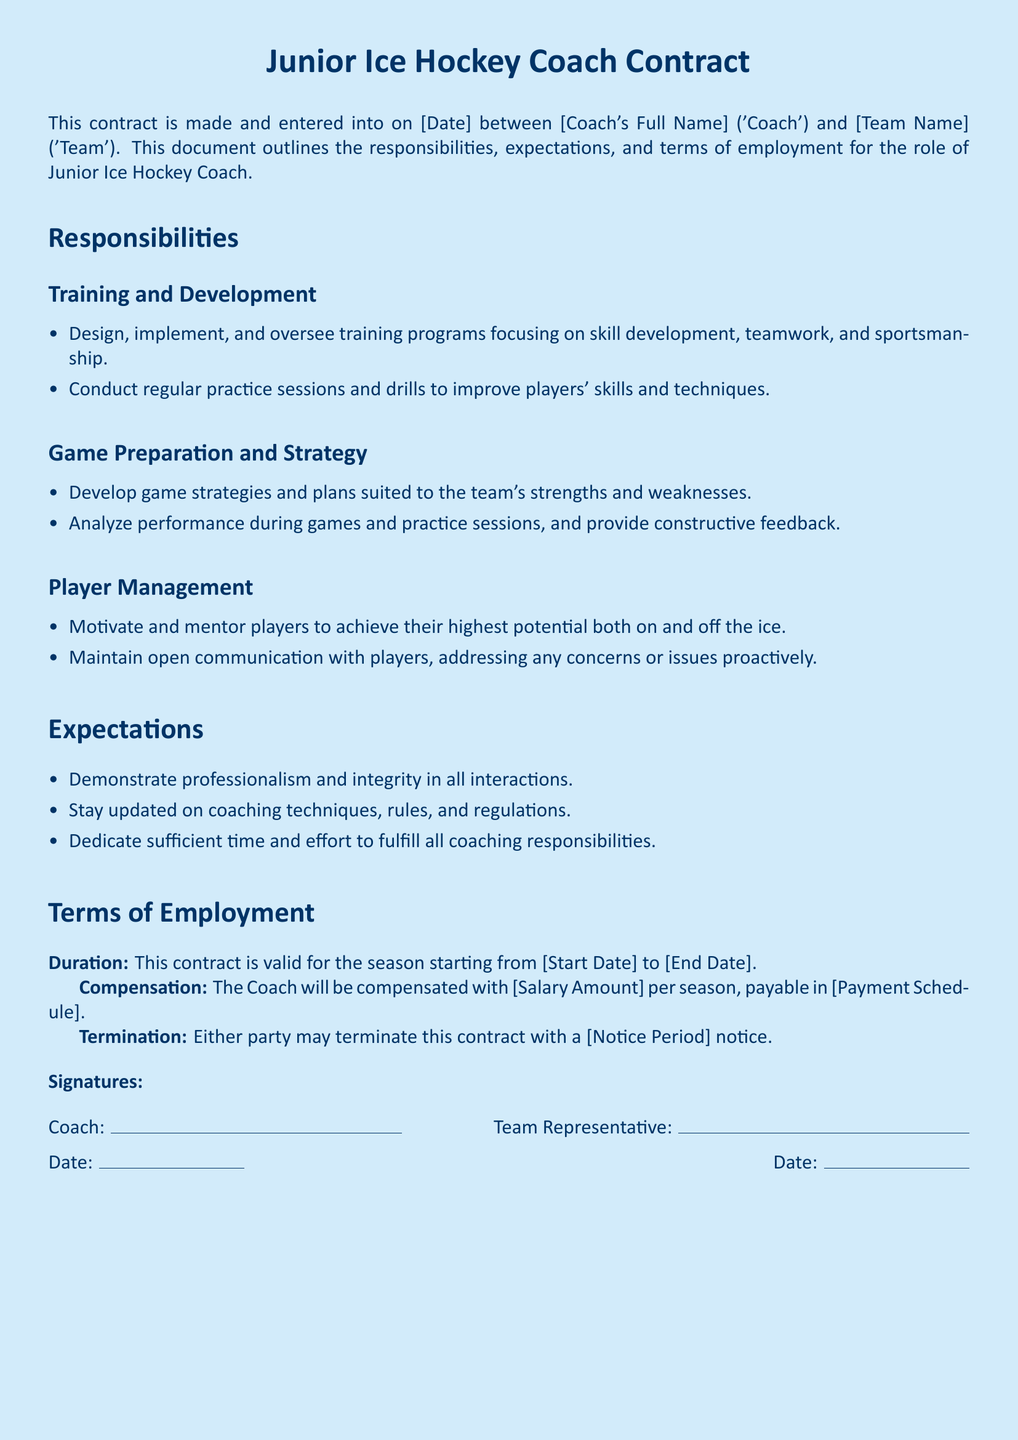What is the effective date of the contract? The effective date of the contract is specified in the section that says it is made on [Date].
Answer: [Date] What is the duration of the contract? The duration is specified in the section stating the contract is valid for the season from [Start Date] to [End Date].
Answer: [Start Date] to [End Date] What is the Coach's full name? The Coach's full name is mentioned at the beginning of the contract under the terms 'Coach' and '[Coach's Full Name]'.
Answer: [Coach's Full Name] What is the salary amount for the Coach? The contract specifies the compensation for the Coach as [Salary Amount] per season.
Answer: [Salary Amount] What is one responsibility of the Coach regarding game preparation? The document outlines a responsibility to develop game strategies and plans suited to the team's strengths and weaknesses.
Answer: Develop game strategies What are the expectations regarding professionalism? The contract specifies the expectation to demonstrate professionalism and integrity in all interactions.
Answer: Professionalism and integrity How much notice is required for termination of the contract? The notice period for termination is specified in the document as [Notice Period].
Answer: [Notice Period] What is the payment schedule for the Coach's compensation? The document states that compensation is payable in [Payment Schedule].
Answer: [Payment Schedule] What is one aspect of player management the Coach should focus on? The contract highlights the need to motivate and mentor players to achieve their highest potential.
Answer: Motivate and mentor players 